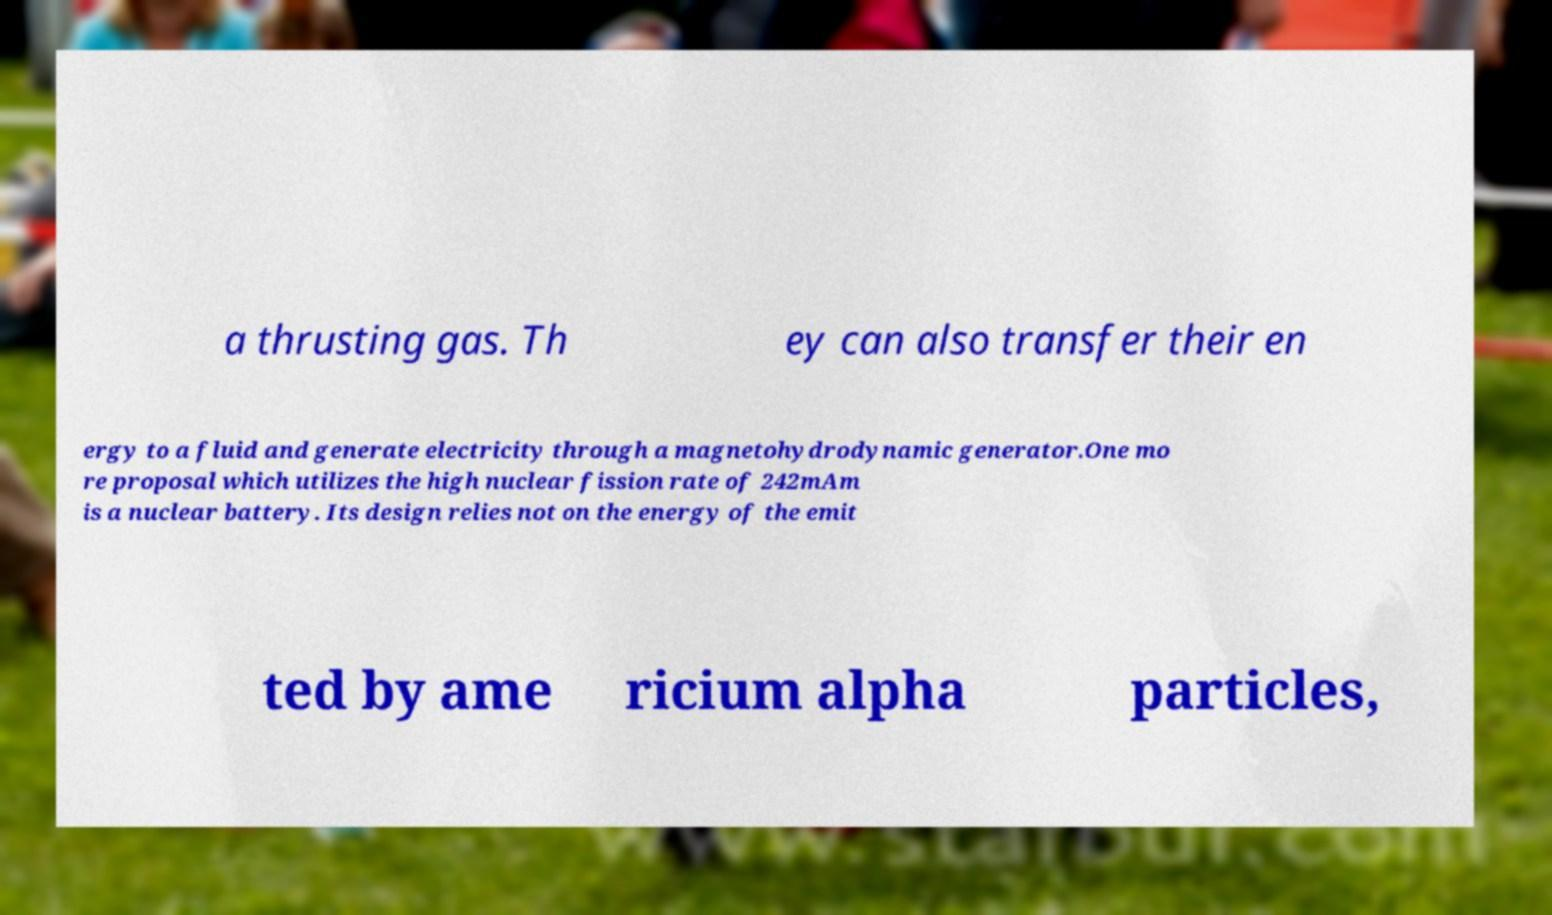Could you assist in decoding the text presented in this image and type it out clearly? a thrusting gas. Th ey can also transfer their en ergy to a fluid and generate electricity through a magnetohydrodynamic generator.One mo re proposal which utilizes the high nuclear fission rate of 242mAm is a nuclear battery. Its design relies not on the energy of the emit ted by ame ricium alpha particles, 